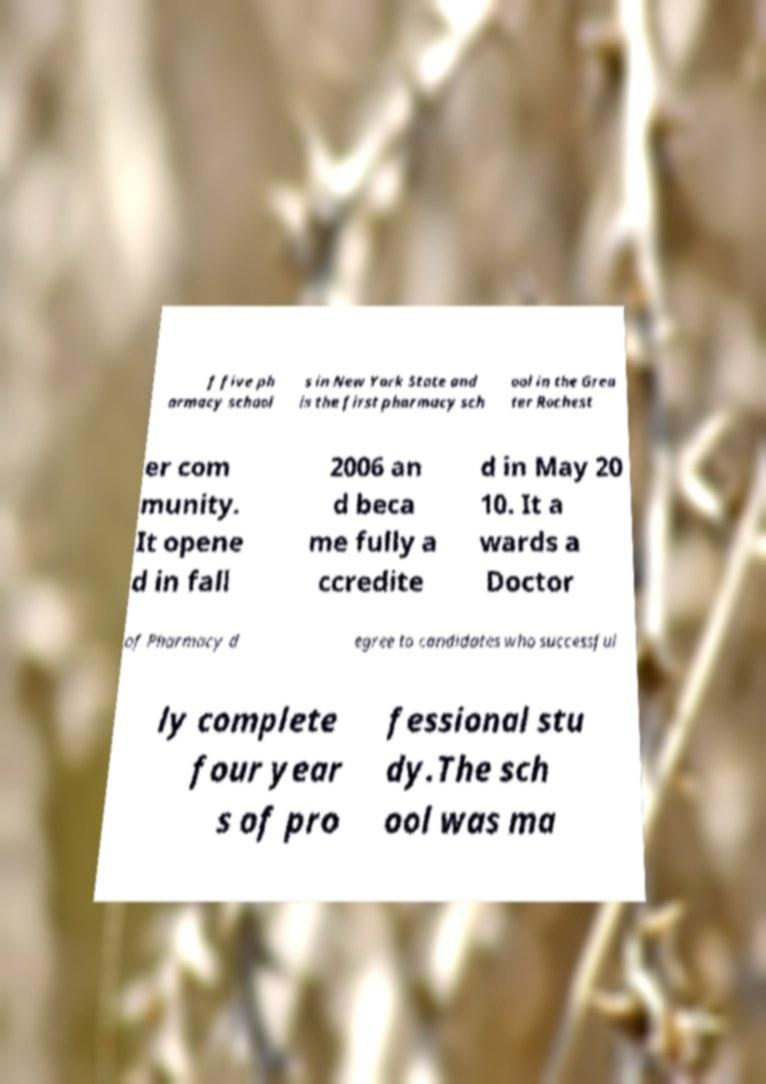For documentation purposes, I need the text within this image transcribed. Could you provide that? f five ph armacy school s in New York State and is the first pharmacy sch ool in the Grea ter Rochest er com munity. It opene d in fall 2006 an d beca me fully a ccredite d in May 20 10. It a wards a Doctor of Pharmacy d egree to candidates who successful ly complete four year s of pro fessional stu dy.The sch ool was ma 